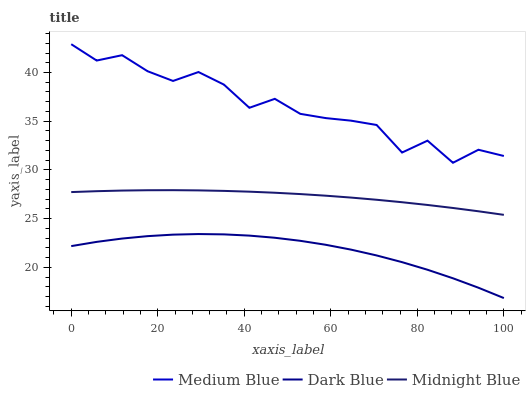Does Dark Blue have the minimum area under the curve?
Answer yes or no. Yes. Does Medium Blue have the maximum area under the curve?
Answer yes or no. Yes. Does Midnight Blue have the minimum area under the curve?
Answer yes or no. No. Does Midnight Blue have the maximum area under the curve?
Answer yes or no. No. Is Midnight Blue the smoothest?
Answer yes or no. Yes. Is Medium Blue the roughest?
Answer yes or no. Yes. Is Medium Blue the smoothest?
Answer yes or no. No. Is Midnight Blue the roughest?
Answer yes or no. No. Does Dark Blue have the lowest value?
Answer yes or no. Yes. Does Midnight Blue have the lowest value?
Answer yes or no. No. Does Medium Blue have the highest value?
Answer yes or no. Yes. Does Midnight Blue have the highest value?
Answer yes or no. No. Is Dark Blue less than Midnight Blue?
Answer yes or no. Yes. Is Medium Blue greater than Midnight Blue?
Answer yes or no. Yes. Does Dark Blue intersect Midnight Blue?
Answer yes or no. No. 